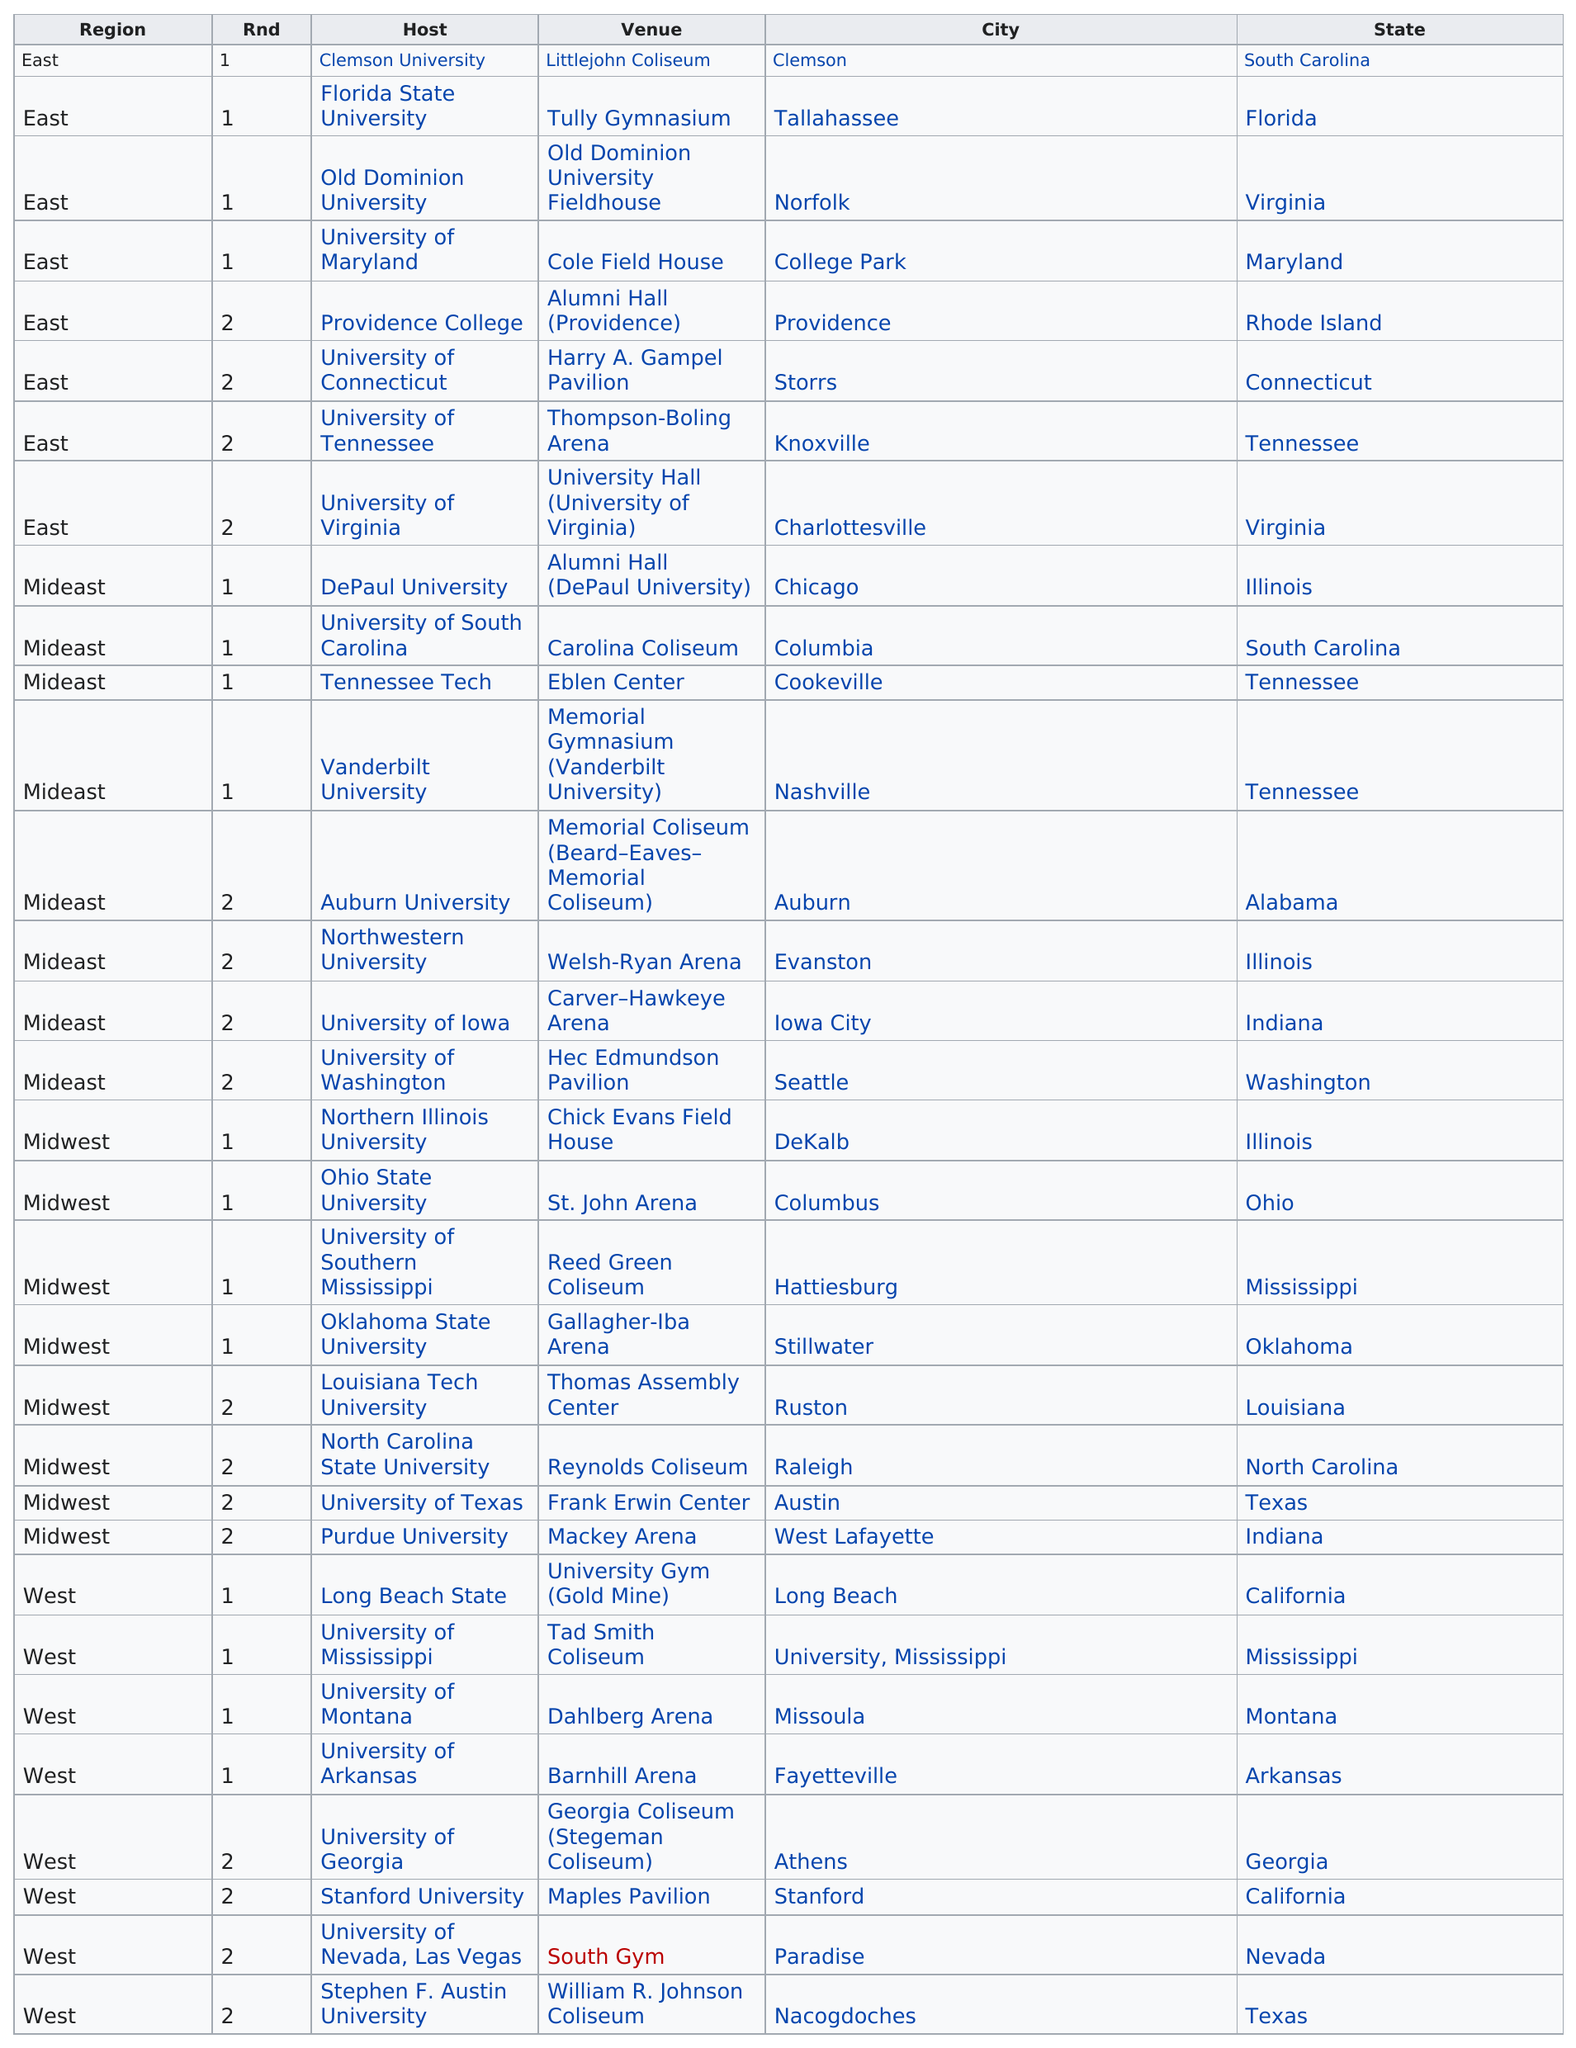Outline some significant characteristics in this image. A total of 32 venues hosted first and second round games. 